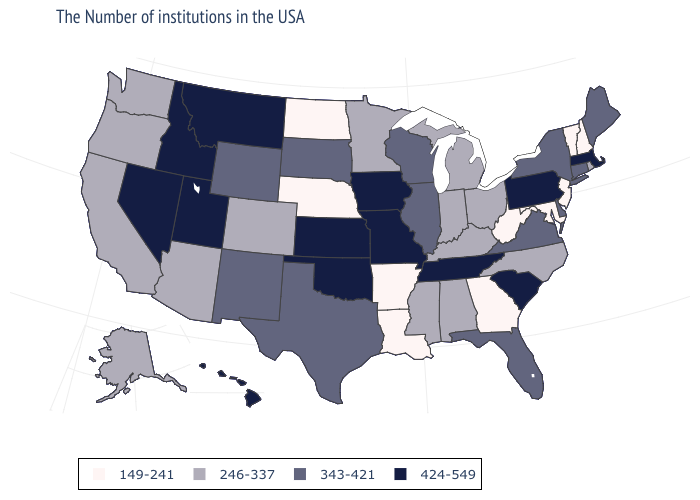Name the states that have a value in the range 424-549?
Concise answer only. Massachusetts, Pennsylvania, South Carolina, Tennessee, Missouri, Iowa, Kansas, Oklahoma, Utah, Montana, Idaho, Nevada, Hawaii. What is the value of Wyoming?
Give a very brief answer. 343-421. Which states have the lowest value in the West?
Be succinct. Colorado, Arizona, California, Washington, Oregon, Alaska. What is the highest value in the Northeast ?
Answer briefly. 424-549. Does Missouri have the same value as Massachusetts?
Answer briefly. Yes. What is the value of Connecticut?
Give a very brief answer. 343-421. Name the states that have a value in the range 246-337?
Answer briefly. Rhode Island, North Carolina, Ohio, Michigan, Kentucky, Indiana, Alabama, Mississippi, Minnesota, Colorado, Arizona, California, Washington, Oregon, Alaska. What is the value of New Jersey?
Keep it brief. 149-241. Does Ohio have the highest value in the MidWest?
Short answer required. No. What is the value of Nebraska?
Be succinct. 149-241. What is the value of California?
Concise answer only. 246-337. How many symbols are there in the legend?
Quick response, please. 4. Which states have the lowest value in the MidWest?
Keep it brief. Nebraska, North Dakota. Does Virginia have the lowest value in the USA?
Answer briefly. No. Name the states that have a value in the range 424-549?
Short answer required. Massachusetts, Pennsylvania, South Carolina, Tennessee, Missouri, Iowa, Kansas, Oklahoma, Utah, Montana, Idaho, Nevada, Hawaii. 